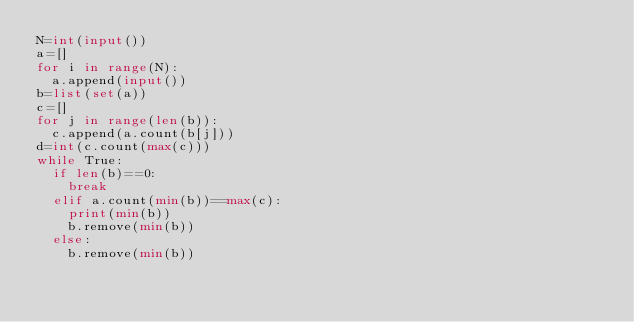Convert code to text. <code><loc_0><loc_0><loc_500><loc_500><_Python_>N=int(input())
a=[]
for i in range(N):
  a.append(input())
b=list(set(a))
c=[]
for j in range(len(b)):
  c.append(a.count(b[j]))
d=int(c.count(max(c)))
while True:
  if len(b)==0:
    break
  elif a.count(min(b))==max(c):
    print(min(b))
    b.remove(min(b))
  else:
    b.remove(min(b))</code> 